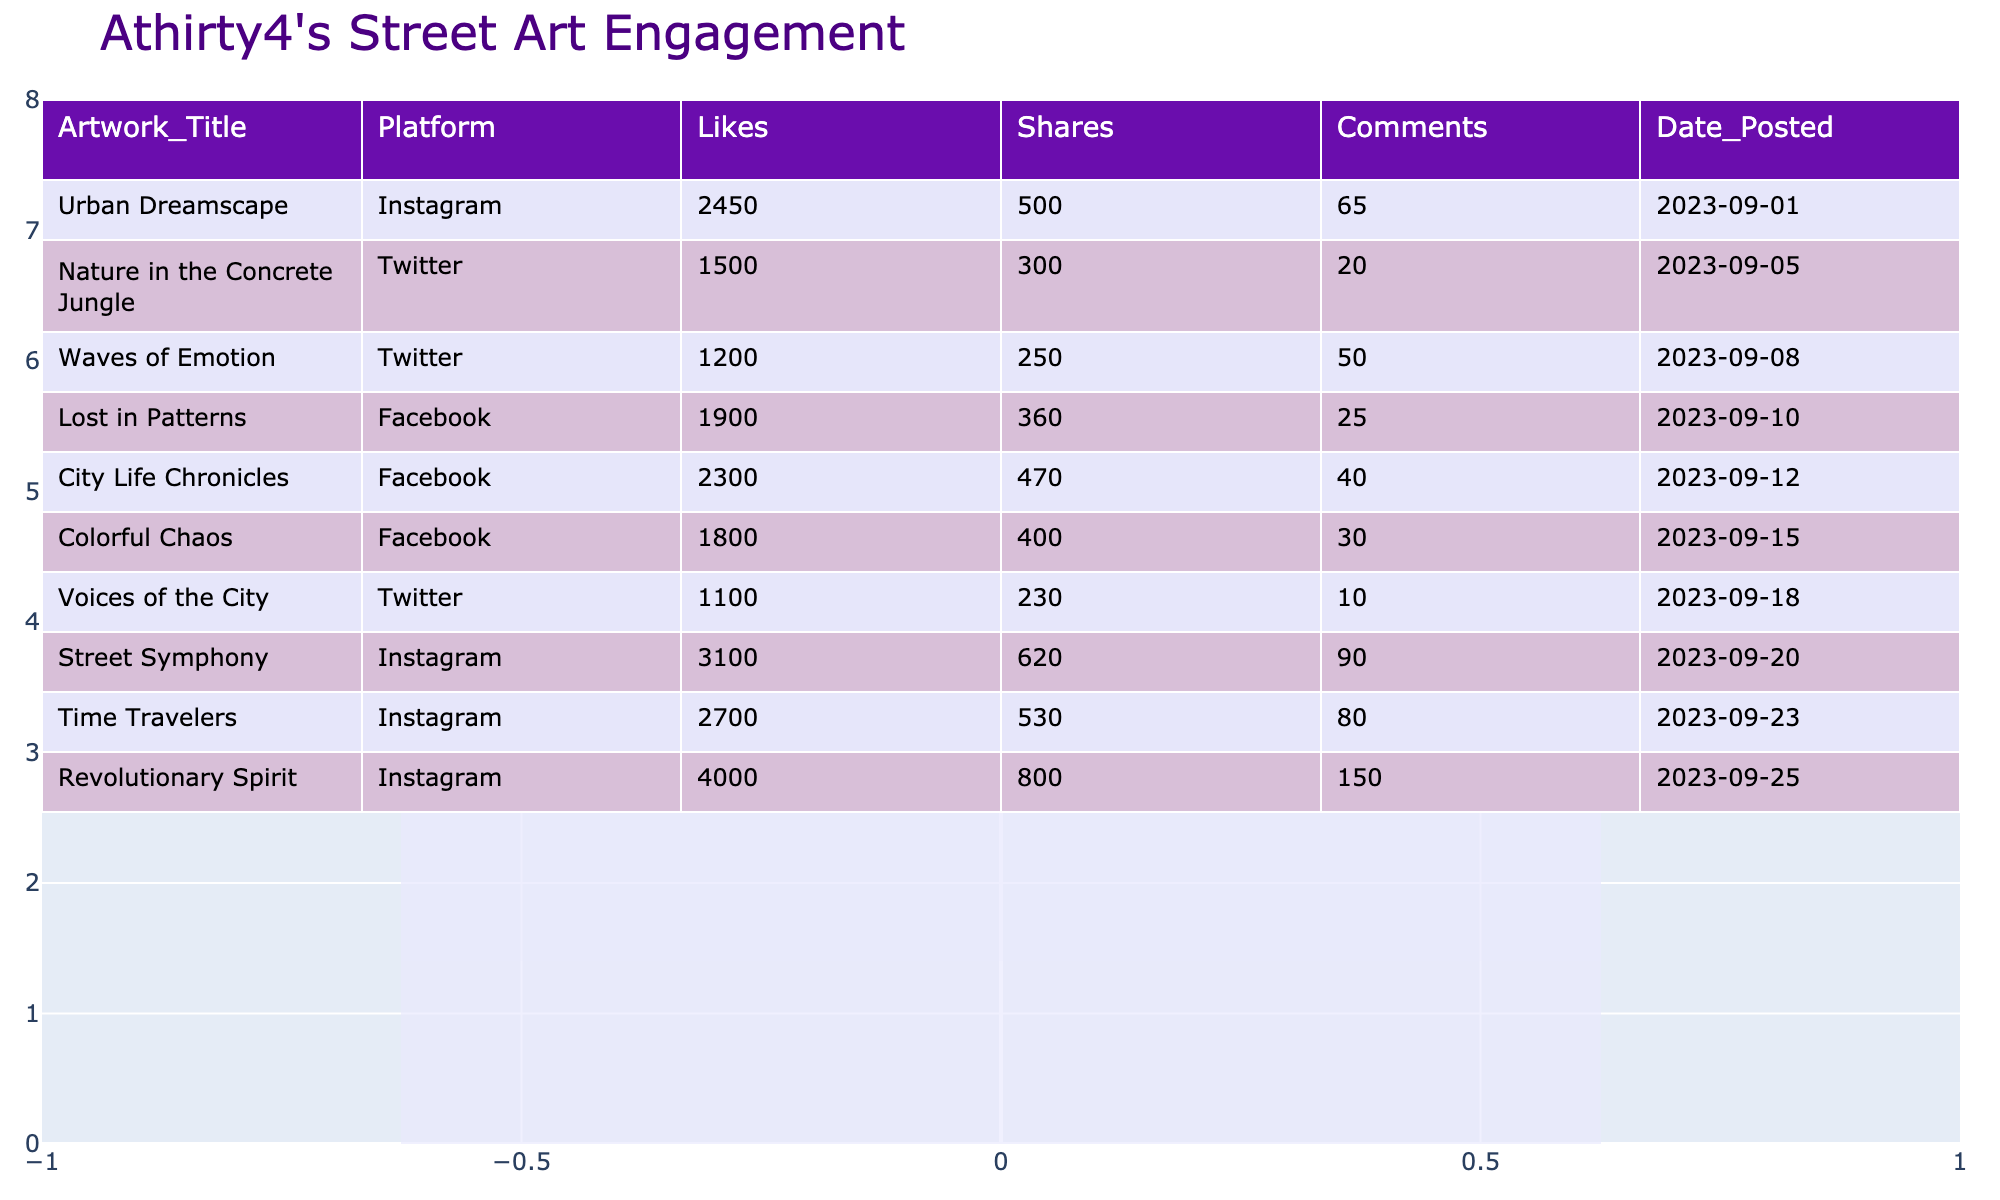What is the title of the artwork with the highest number of likes? Looking at the Likes column, "Revolutionary Spirit" has the highest value at 4000. Therefore, the title of the artwork with the highest number of likes is "Revolutionary Spirit".
Answer: Revolutionary Spirit Which platform had the most shares for Athirty4's street art? By observing the Shares column, "Revolutionary Spirit" on Instagram has the highest number of shares at 800. Since this is the maximum value in the Shares column, Instagram had the most shares.
Answer: Instagram What is the average number of likes across all artworks? To find the average, we first need to sum all likes: 2450 + 1800 + 1200 + 3100 + 2300 + 1500 + 4000 + 1900 + 1100 + 2700 = 22050. Then, we divide by the number of artworks, which is 10. Thus, the average number of likes is 22050/10 = 2205.
Answer: 2205 Did "Waves of Emotion" receive more comments than "Voices of the City"? "Waves of Emotion" has 50 comments and "Voices of the City" has 10 comments. Since 50 is greater than 10, the statement is true.
Answer: Yes What is the total number of comments made on artworks posted in September? We consider only the artworks from September: "Urban Dreamscape" (65), "Waves of Emotion" (50), "City Life Chronicles" (40), "Lost in Patterns" (25), and "Time Travelers" (80). The total comments are 65 + 50 + 40 + 25 + 80 = 260.
Answer: 260 